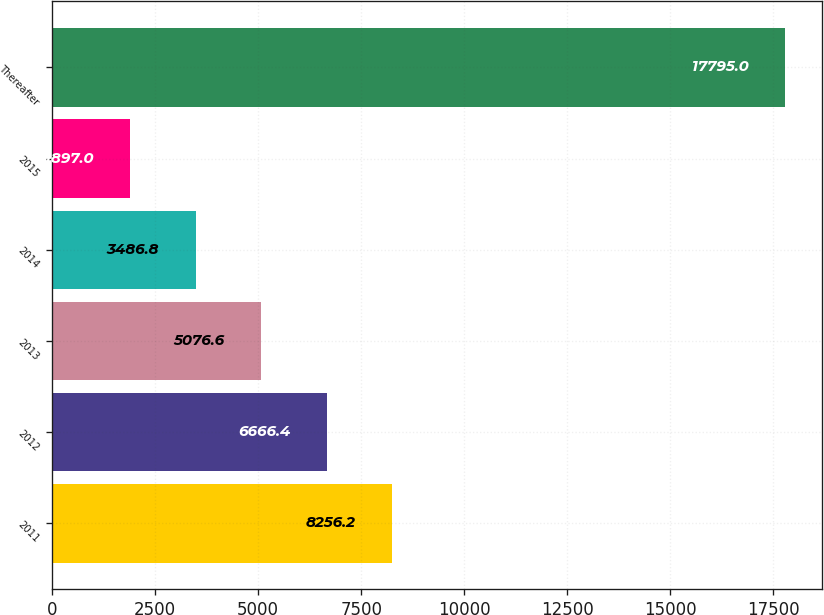Convert chart. <chart><loc_0><loc_0><loc_500><loc_500><bar_chart><fcel>2011<fcel>2012<fcel>2013<fcel>2014<fcel>2015<fcel>Thereafter<nl><fcel>8256.2<fcel>6666.4<fcel>5076.6<fcel>3486.8<fcel>1897<fcel>17795<nl></chart> 